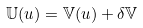<formula> <loc_0><loc_0><loc_500><loc_500>\mathbb { U } ( u ) = \mathbb { V } ( u ) + \delta \mathbb { V }</formula> 